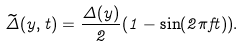<formula> <loc_0><loc_0><loc_500><loc_500>\widetilde { \Delta } ( y , t ) = \frac { \Delta ( y ) } { 2 } ( 1 - \sin ( 2 \pi f t ) ) .</formula> 